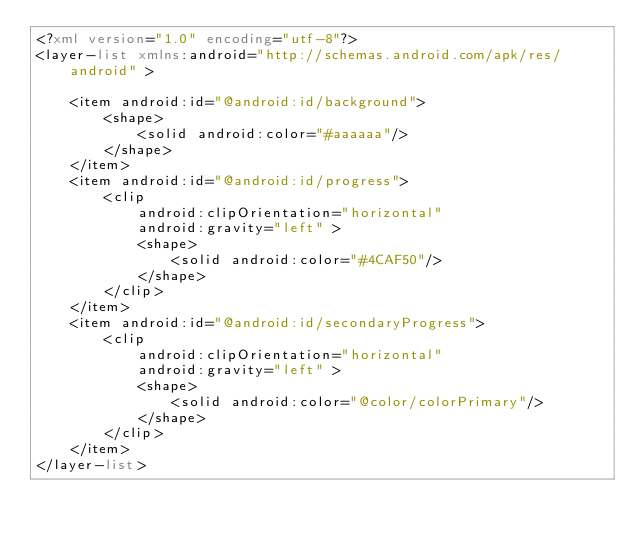<code> <loc_0><loc_0><loc_500><loc_500><_XML_><?xml version="1.0" encoding="utf-8"?>
<layer-list xmlns:android="http://schemas.android.com/apk/res/android" >

    <item android:id="@android:id/background">
        <shape>
            <solid android:color="#aaaaaa"/>
        </shape>
    </item>
    <item android:id="@android:id/progress">
        <clip
            android:clipOrientation="horizontal"
            android:gravity="left" >
            <shape>
                <solid android:color="#4CAF50"/>
            </shape>
        </clip>
    </item>
    <item android:id="@android:id/secondaryProgress">
        <clip
            android:clipOrientation="horizontal"
            android:gravity="left" >
            <shape>
                <solid android:color="@color/colorPrimary"/>
            </shape>
        </clip>
    </item>
</layer-list>
</code> 